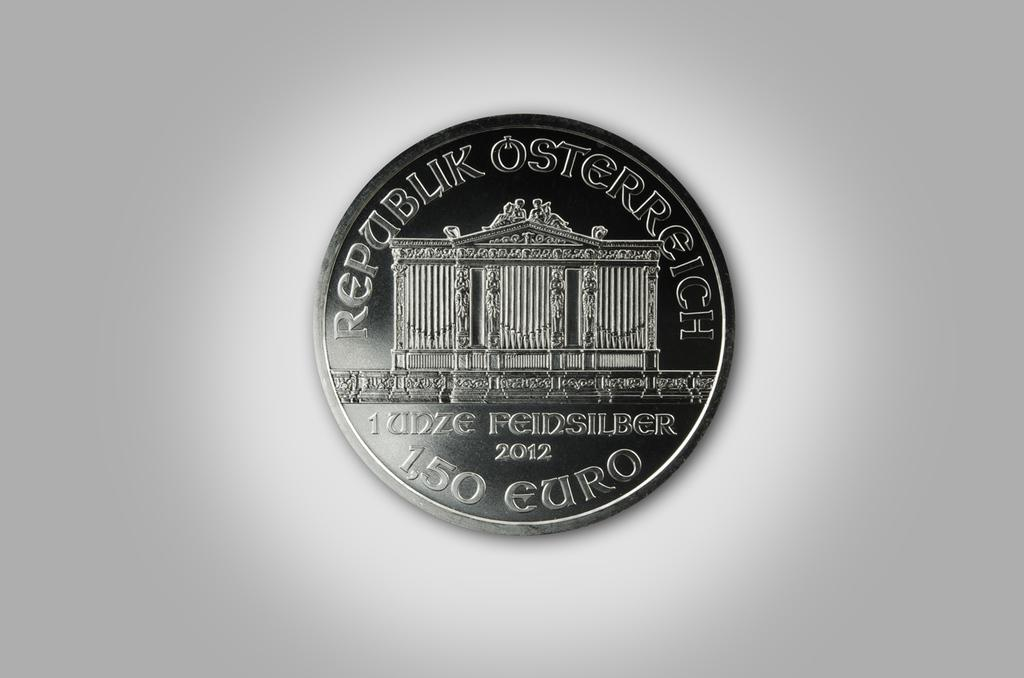<image>
Summarize the visual content of the image. Silver coin showing a building and words that say "Republik Osterreich". 